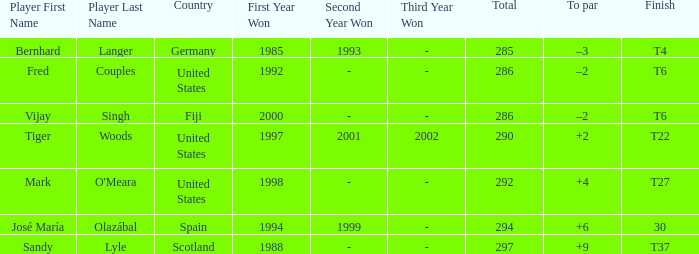Which player has a total of more than 290 and +4 to par. Mark O'Meara. 